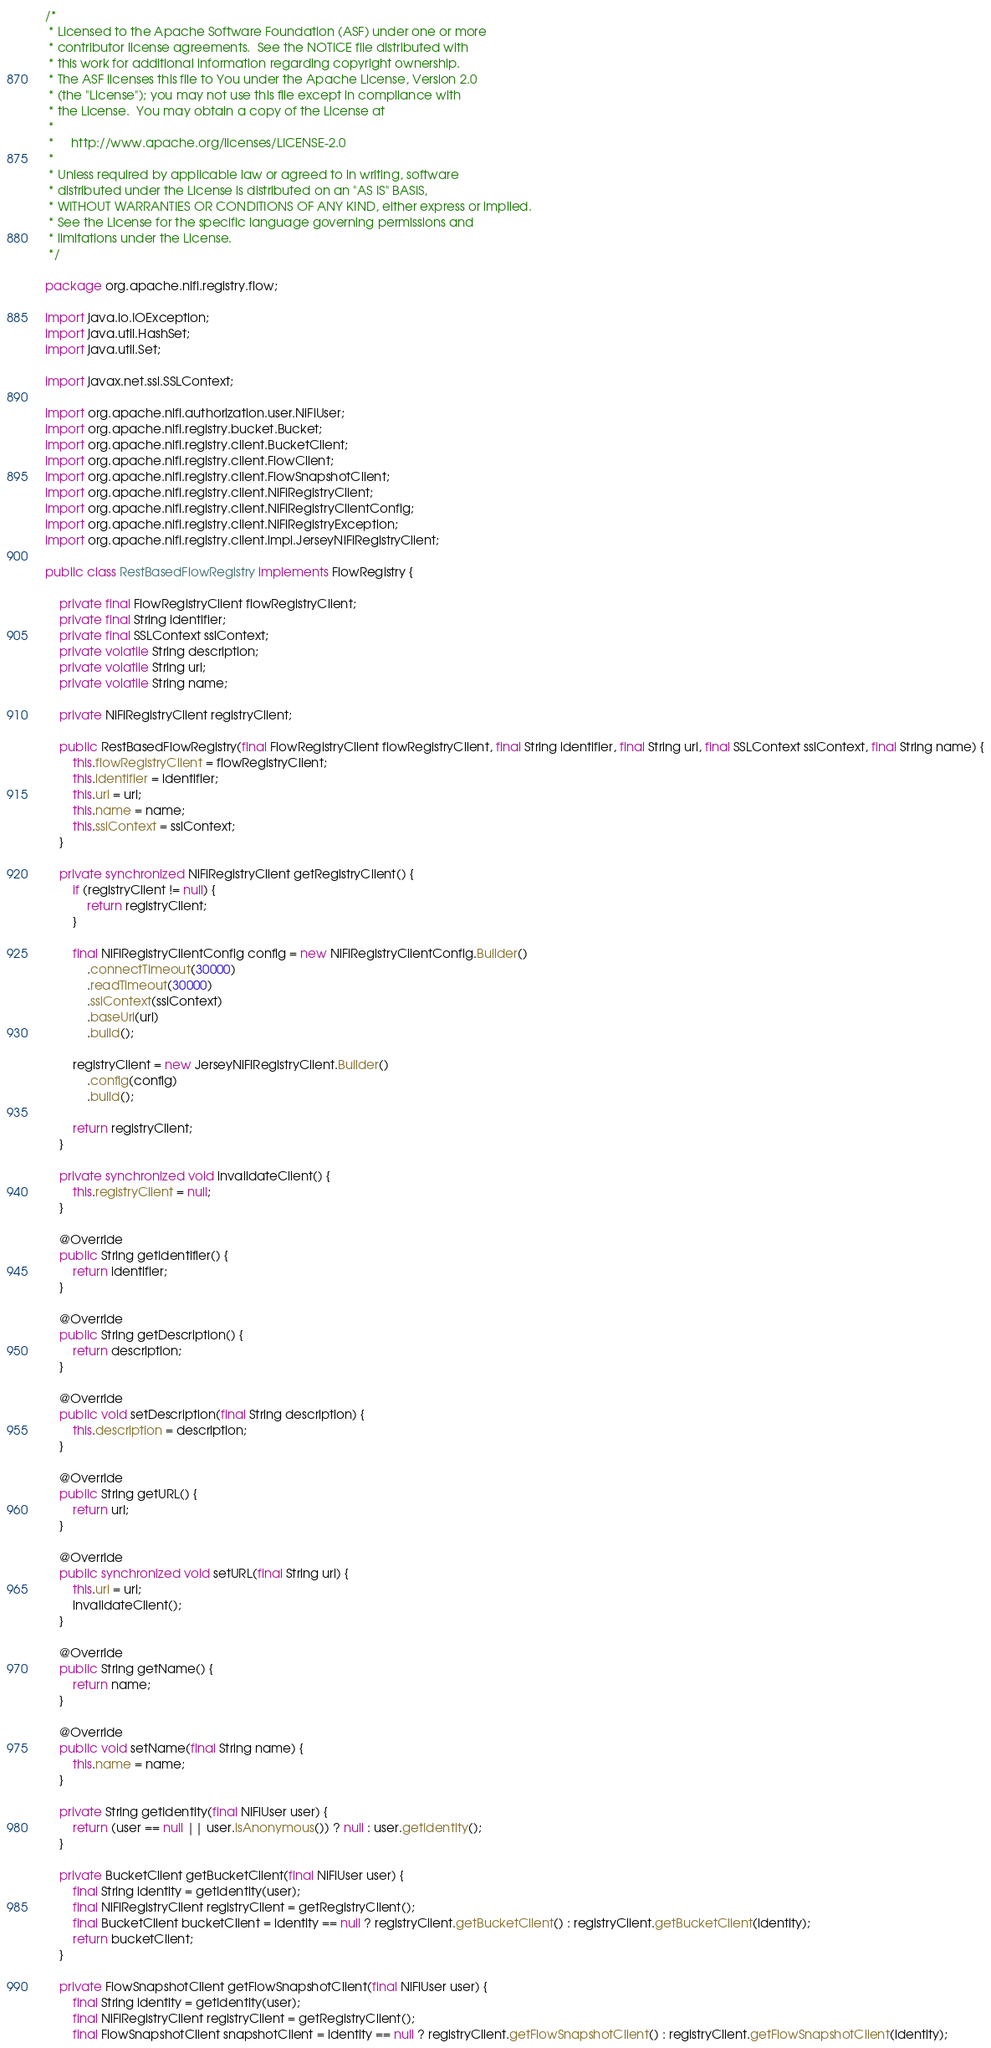<code> <loc_0><loc_0><loc_500><loc_500><_Java_>/*
 * Licensed to the Apache Software Foundation (ASF) under one or more
 * contributor license agreements.  See the NOTICE file distributed with
 * this work for additional information regarding copyright ownership.
 * The ASF licenses this file to You under the Apache License, Version 2.0
 * (the "License"); you may not use this file except in compliance with
 * the License.  You may obtain a copy of the License at
 *
 *     http://www.apache.org/licenses/LICENSE-2.0
 *
 * Unless required by applicable law or agreed to in writing, software
 * distributed under the License is distributed on an "AS IS" BASIS,
 * WITHOUT WARRANTIES OR CONDITIONS OF ANY KIND, either express or implied.
 * See the License for the specific language governing permissions and
 * limitations under the License.
 */

package org.apache.nifi.registry.flow;

import java.io.IOException;
import java.util.HashSet;
import java.util.Set;

import javax.net.ssl.SSLContext;

import org.apache.nifi.authorization.user.NiFiUser;
import org.apache.nifi.registry.bucket.Bucket;
import org.apache.nifi.registry.client.BucketClient;
import org.apache.nifi.registry.client.FlowClient;
import org.apache.nifi.registry.client.FlowSnapshotClient;
import org.apache.nifi.registry.client.NiFiRegistryClient;
import org.apache.nifi.registry.client.NiFiRegistryClientConfig;
import org.apache.nifi.registry.client.NiFiRegistryException;
import org.apache.nifi.registry.client.impl.JerseyNiFiRegistryClient;

public class RestBasedFlowRegistry implements FlowRegistry {

    private final FlowRegistryClient flowRegistryClient;
    private final String identifier;
    private final SSLContext sslContext;
    private volatile String description;
    private volatile String url;
    private volatile String name;

    private NiFiRegistryClient registryClient;

    public RestBasedFlowRegistry(final FlowRegistryClient flowRegistryClient, final String identifier, final String url, final SSLContext sslContext, final String name) {
        this.flowRegistryClient = flowRegistryClient;
        this.identifier = identifier;
        this.url = url;
        this.name = name;
        this.sslContext = sslContext;
    }

    private synchronized NiFiRegistryClient getRegistryClient() {
        if (registryClient != null) {
            return registryClient;
        }

        final NiFiRegistryClientConfig config = new NiFiRegistryClientConfig.Builder()
            .connectTimeout(30000)
            .readTimeout(30000)
            .sslContext(sslContext)
            .baseUrl(url)
            .build();

        registryClient = new JerseyNiFiRegistryClient.Builder()
            .config(config)
            .build();

        return registryClient;
    }

    private synchronized void invalidateClient() {
        this.registryClient = null;
    }

    @Override
    public String getIdentifier() {
        return identifier;
    }

    @Override
    public String getDescription() {
        return description;
    }

    @Override
    public void setDescription(final String description) {
        this.description = description;
    }

    @Override
    public String getURL() {
        return url;
    }

    @Override
    public synchronized void setURL(final String url) {
        this.url = url;
        invalidateClient();
    }

    @Override
    public String getName() {
        return name;
    }

    @Override
    public void setName(final String name) {
        this.name = name;
    }

    private String getIdentity(final NiFiUser user) {
        return (user == null || user.isAnonymous()) ? null : user.getIdentity();
    }

    private BucketClient getBucketClient(final NiFiUser user) {
        final String identity = getIdentity(user);
        final NiFiRegistryClient registryClient = getRegistryClient();
        final BucketClient bucketClient = identity == null ? registryClient.getBucketClient() : registryClient.getBucketClient(identity);
        return bucketClient;
    }

    private FlowSnapshotClient getFlowSnapshotClient(final NiFiUser user) {
        final String identity = getIdentity(user);
        final NiFiRegistryClient registryClient = getRegistryClient();
        final FlowSnapshotClient snapshotClient = identity == null ? registryClient.getFlowSnapshotClient() : registryClient.getFlowSnapshotClient(identity);</code> 